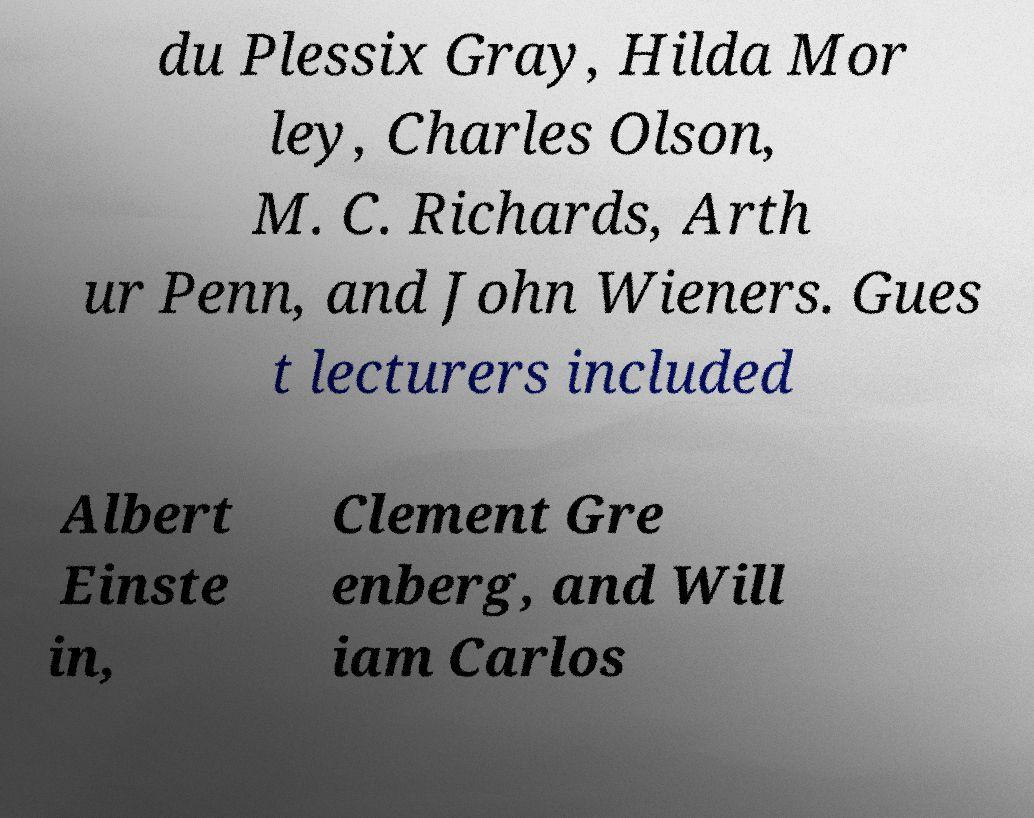Could you extract and type out the text from this image? du Plessix Gray, Hilda Mor ley, Charles Olson, M. C. Richards, Arth ur Penn, and John Wieners. Gues t lecturers included Albert Einste in, Clement Gre enberg, and Will iam Carlos 